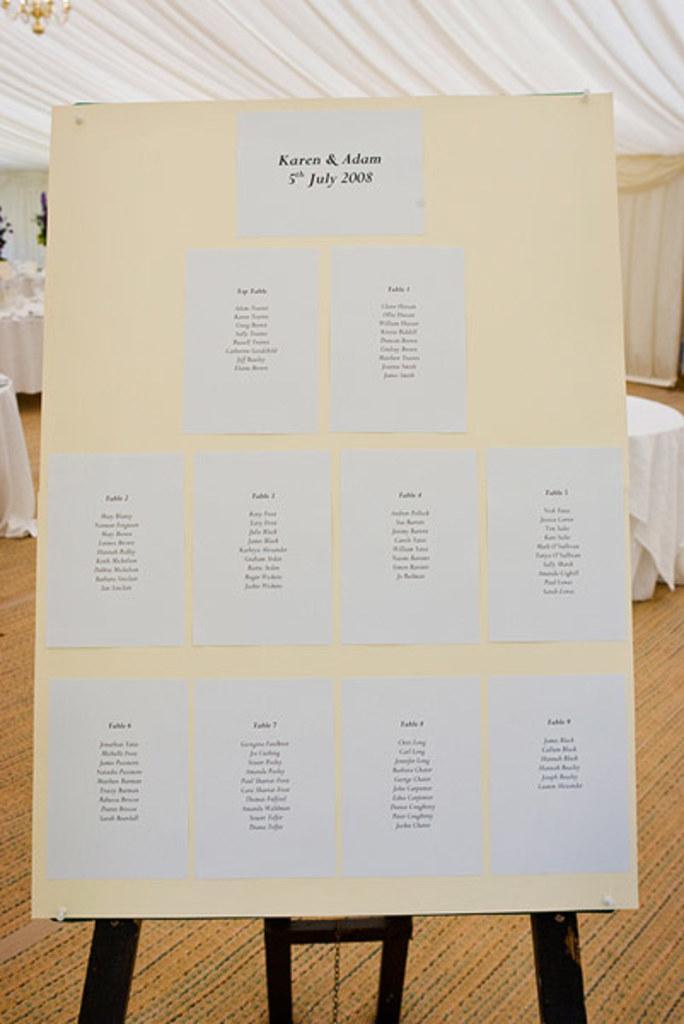Can you describe this image briefly? In this picture we can see a board with posters on it and in the background we can see tables, curtains and some objects. 